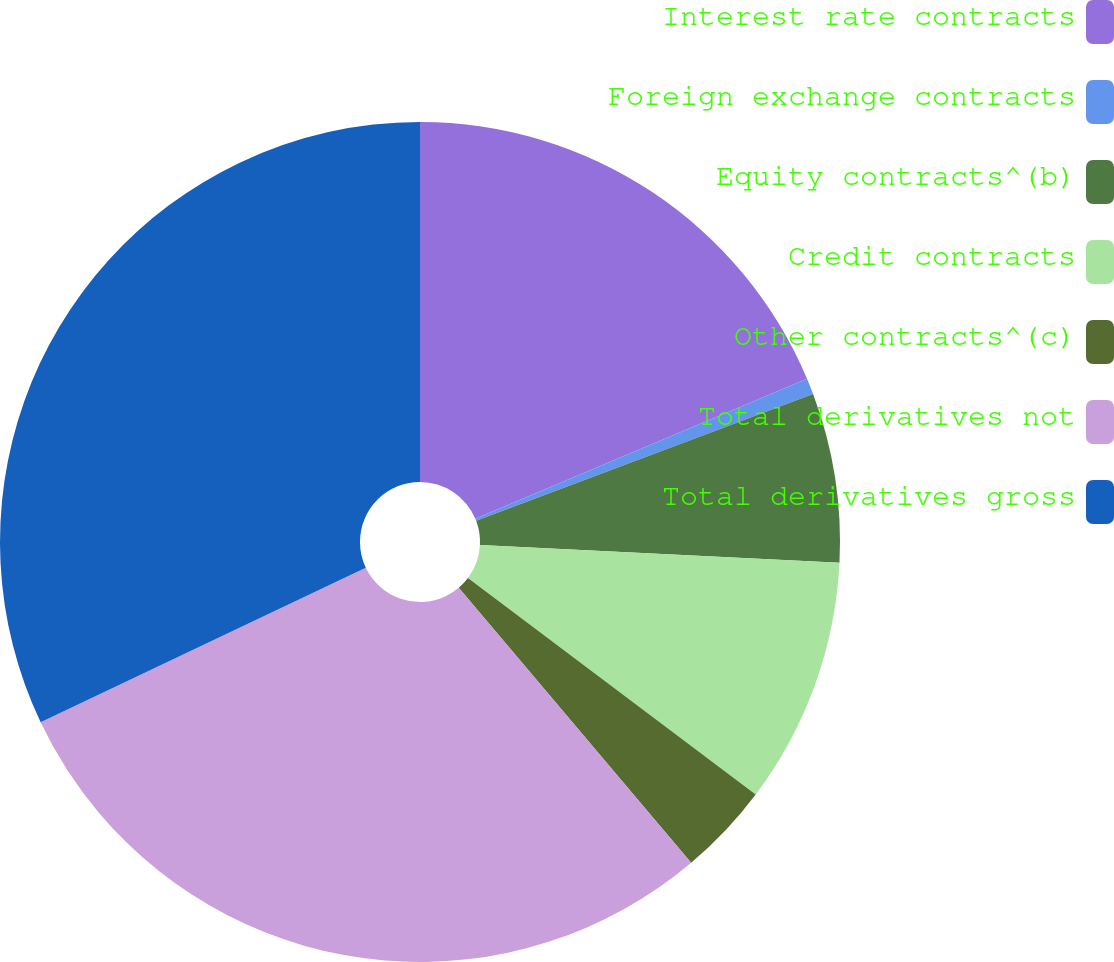Convert chart to OTSL. <chart><loc_0><loc_0><loc_500><loc_500><pie_chart><fcel>Interest rate contracts<fcel>Foreign exchange contracts<fcel>Equity contracts^(b)<fcel>Credit contracts<fcel>Other contracts^(c)<fcel>Total derivatives not<fcel>Total derivatives gross<nl><fcel>18.65%<fcel>0.62%<fcel>6.52%<fcel>9.47%<fcel>3.57%<fcel>29.11%<fcel>32.06%<nl></chart> 